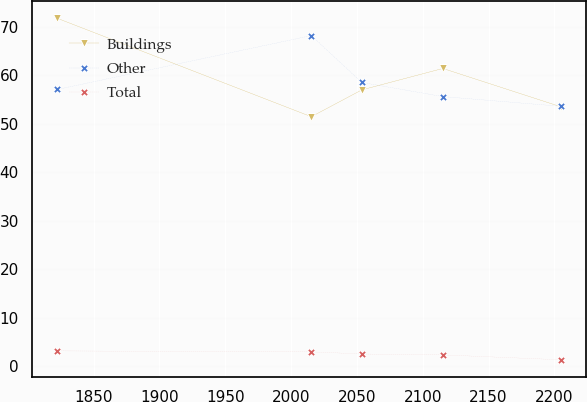<chart> <loc_0><loc_0><loc_500><loc_500><line_chart><ecel><fcel>Buildings<fcel>Other<fcel>Total<nl><fcel>1822.26<fcel>71.72<fcel>57.05<fcel>3.21<nl><fcel>2015.37<fcel>51.44<fcel>68.15<fcel>3.02<nl><fcel>2053.66<fcel>56.96<fcel>58.51<fcel>2.58<nl><fcel>2115.29<fcel>61.38<fcel>55.59<fcel>2.39<nl><fcel>2205.21<fcel>53.47<fcel>53.58<fcel>1.38<nl></chart> 